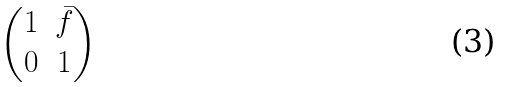Convert formula to latex. <formula><loc_0><loc_0><loc_500><loc_500>\begin{pmatrix} 1 & \bar { f } \\ 0 & 1 \end{pmatrix}</formula> 